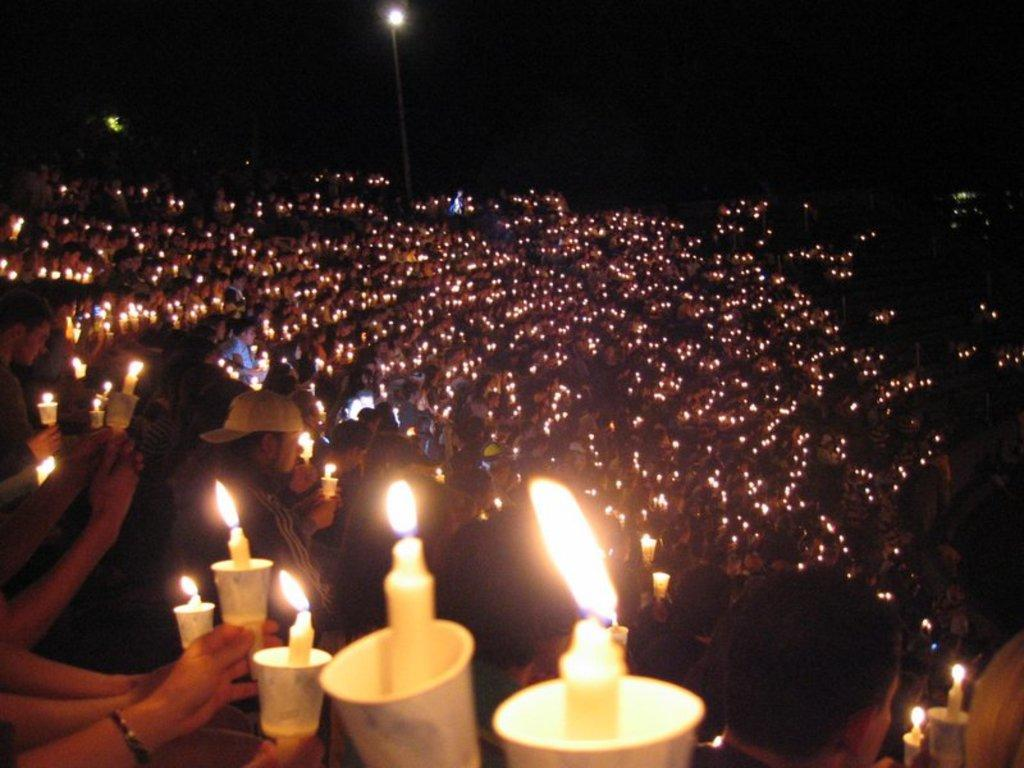How many people are in the image? There are people in the image, but the exact number is not specified. What are some of the people holding in the image? Some of the people are holding cups and some are holding candles. What is the purpose of the light pole in the image? The light pole provides illumination in the image. How would you describe the background of the image? The background of the image is dark. What type of news can be heard coming from the radio in the image? There is no radio present in the image, so it is not possible to determine what news might be heard. 